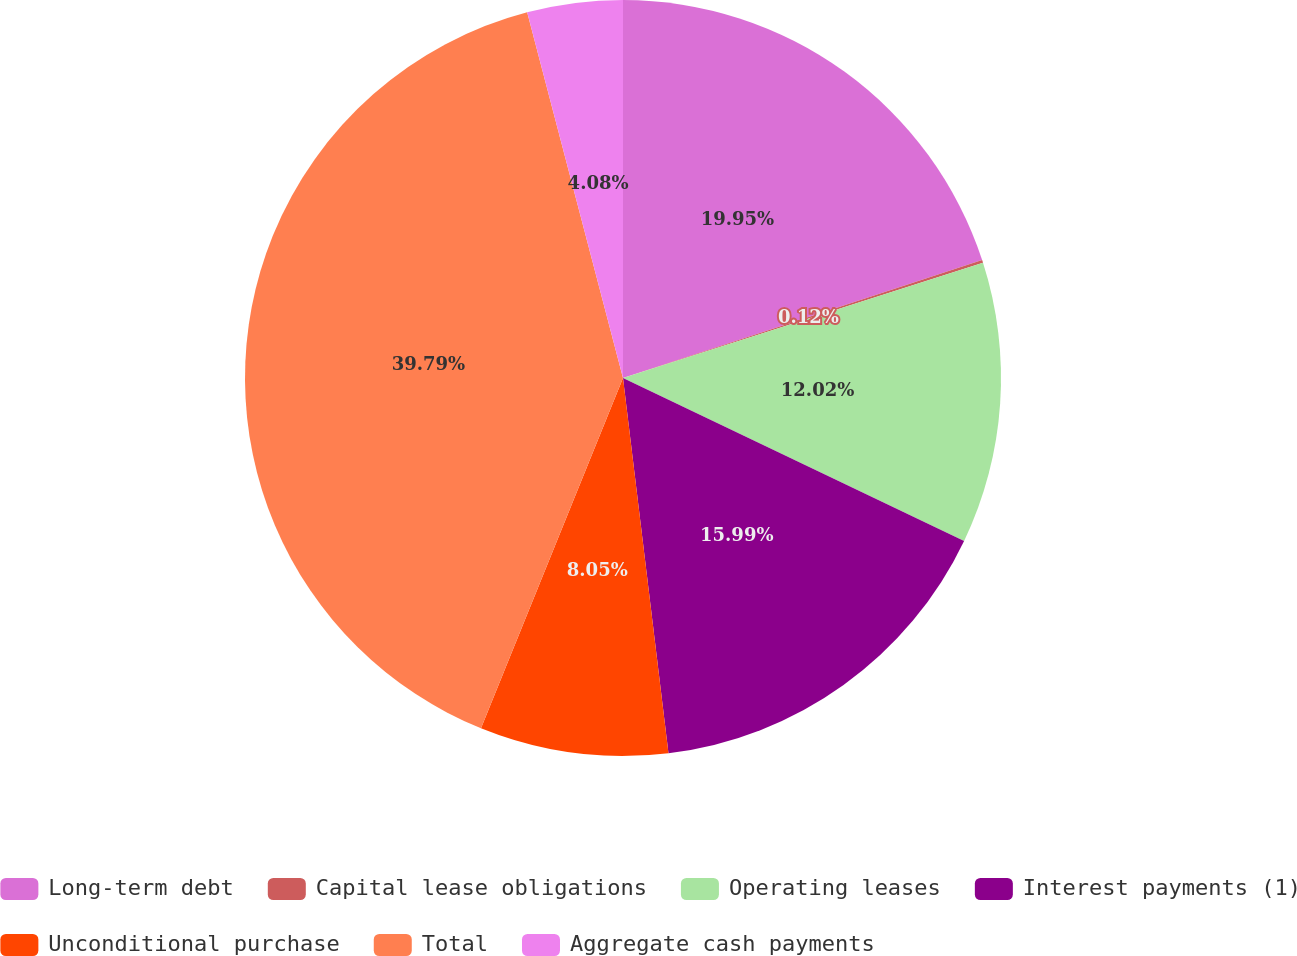Convert chart. <chart><loc_0><loc_0><loc_500><loc_500><pie_chart><fcel>Long-term debt<fcel>Capital lease obligations<fcel>Operating leases<fcel>Interest payments (1)<fcel>Unconditional purchase<fcel>Total<fcel>Aggregate cash payments<nl><fcel>19.95%<fcel>0.12%<fcel>12.02%<fcel>15.99%<fcel>8.05%<fcel>39.79%<fcel>4.08%<nl></chart> 